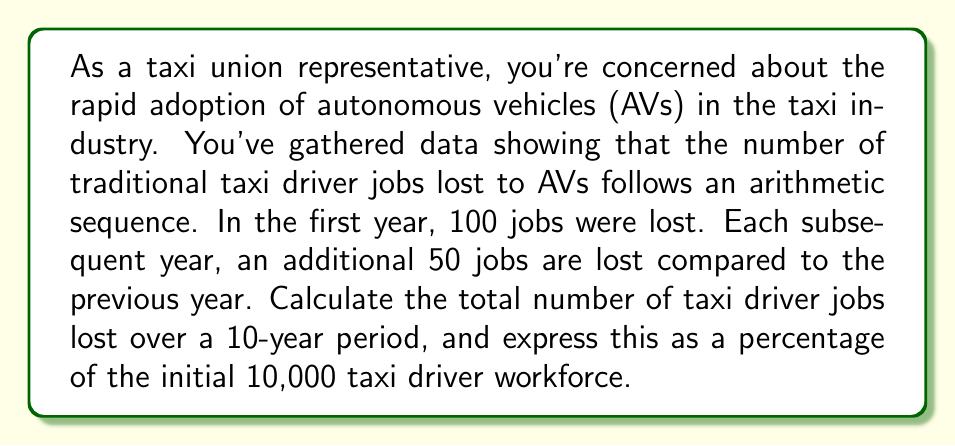Can you answer this question? Let's approach this step-by-step using arithmetic sequence and series concepts:

1) First, let's identify the components of our arithmetic sequence:
   $a_1 = 100$ (first term: jobs lost in the first year)
   $d = 50$ (common difference: additional jobs lost each year)
   $n = 10$ (number of terms: years in the period)

2) The arithmetic sequence of job losses each year would be:
   100, 150, 200, 250, 300, 350, 400, 450, 500, 550

3) To find the total number of jobs lost, we need to sum this sequence. We can use the formula for the sum of an arithmetic series:

   $$S_n = \frac{n}{2}(a_1 + a_n)$$

   Where $a_n$ is the last term, which we can calculate using the arithmetic sequence formula:
   $$a_n = a_1 + (n-1)d$$

4) Let's calculate $a_n$:
   $$a_{10} = 100 + (10-1)50 = 100 + 450 = 550$$

5) Now we can calculate the sum:
   $$S_{10} = \frac{10}{2}(100 + 550) = 5(650) = 3,250$$

6) To express this as a percentage of the initial workforce:
   $$\text{Percentage} = \frac{\text{Jobs lost}}{\text{Initial workforce}} \times 100\%$$
   $$= \frac{3,250}{10,000} \times 100\% = 32.5\%$$
Answer: Over the 10-year period, a total of 3,250 taxi driver jobs would be lost, which represents 32.5% of the initial workforce. 